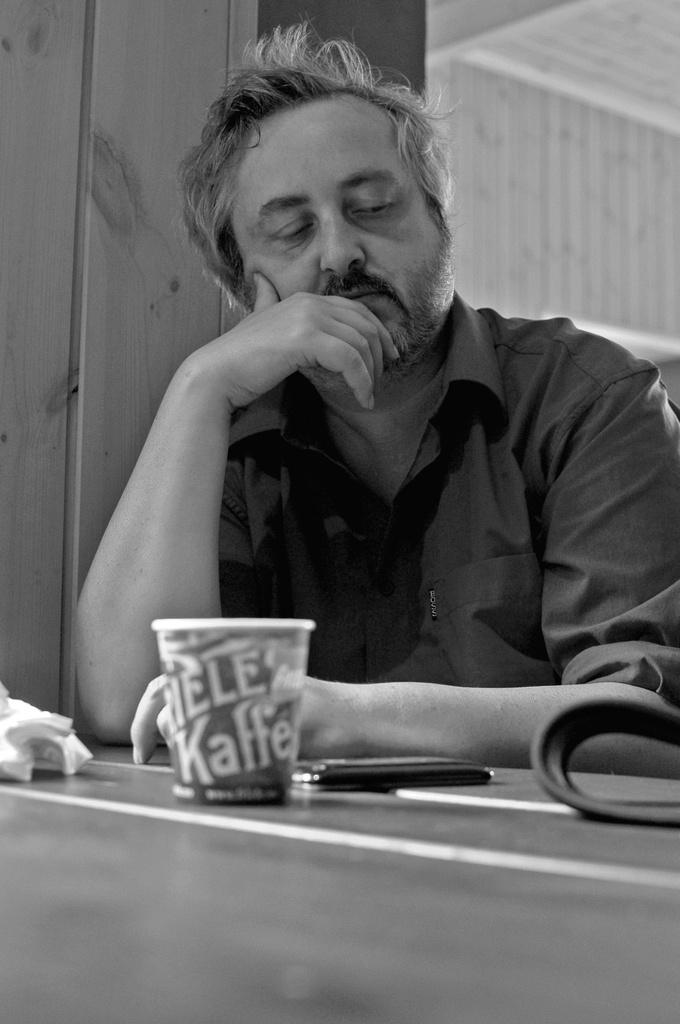Who is present in the image? There is a man in the image. What is the man doing in the image? The man is sitting. What objects can be seen on the table in the image? There is a glass and a mobile phone on the table. What is the color scheme of the image? The image is in black and white color. Can you see a ladybug crawling on the man's shoulder in the image? No, there is no ladybug present in the image. 